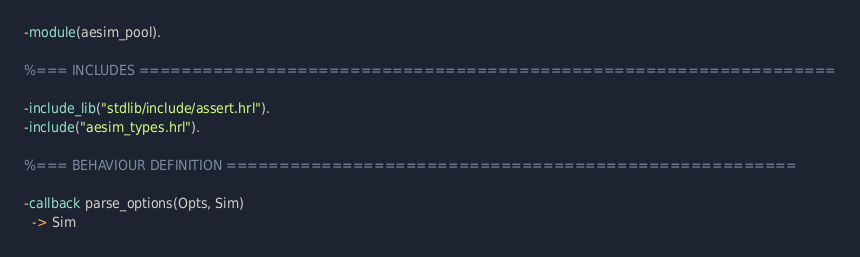<code> <loc_0><loc_0><loc_500><loc_500><_Erlang_>-module(aesim_pool).

%=== INCLUDES ==================================================================

-include_lib("stdlib/include/assert.hrl").
-include("aesim_types.hrl").

%=== BEHAVIOUR DEFINITION ======================================================

-callback parse_options(Opts, Sim)
  -> Sim</code> 